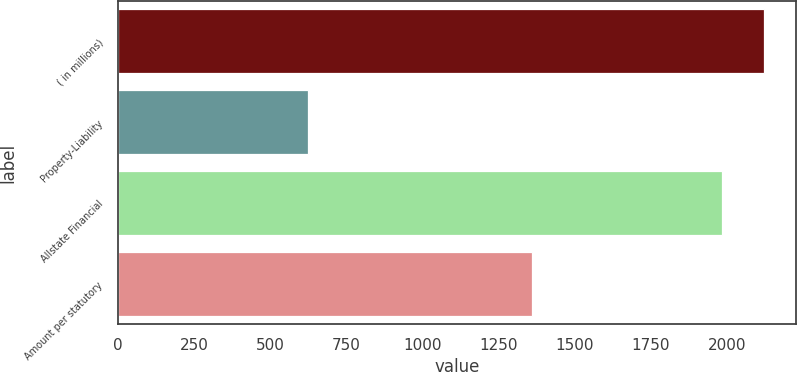Convert chart. <chart><loc_0><loc_0><loc_500><loc_500><bar_chart><fcel>( in millions)<fcel>Property-Liability<fcel>Allstate Financial<fcel>Amount per statutory<nl><fcel>2121.4<fcel>624<fcel>1983<fcel>1359<nl></chart> 